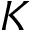Convert formula to latex. <formula><loc_0><loc_0><loc_500><loc_500>K</formula> 